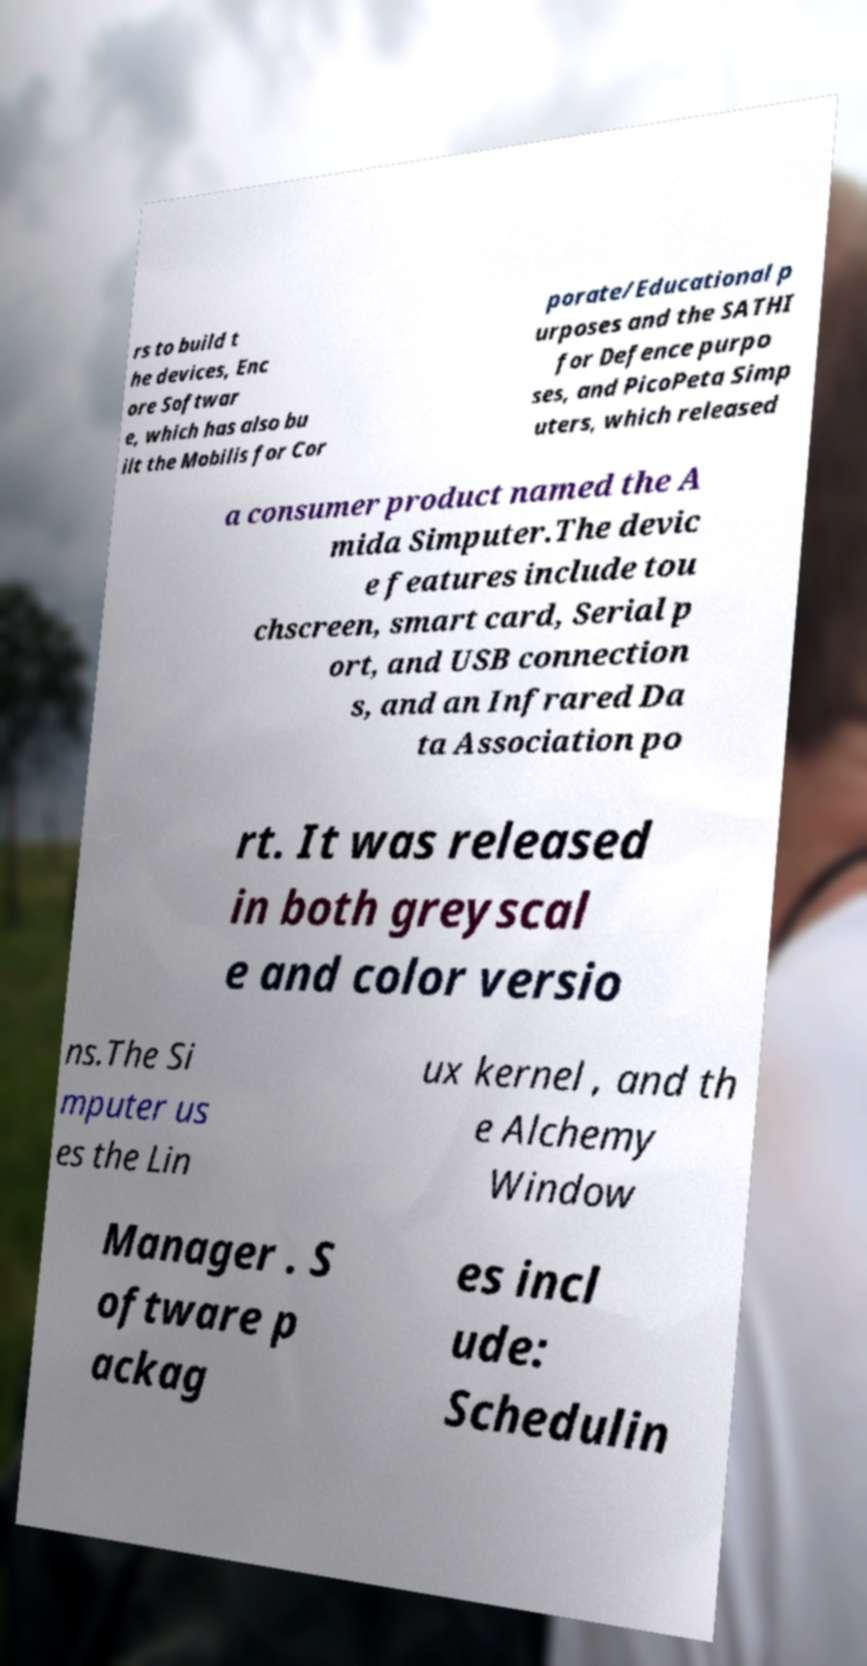Could you extract and type out the text from this image? rs to build t he devices, Enc ore Softwar e, which has also bu ilt the Mobilis for Cor porate/Educational p urposes and the SATHI for Defence purpo ses, and PicoPeta Simp uters, which released a consumer product named the A mida Simputer.The devic e features include tou chscreen, smart card, Serial p ort, and USB connection s, and an Infrared Da ta Association po rt. It was released in both greyscal e and color versio ns.The Si mputer us es the Lin ux kernel , and th e Alchemy Window Manager . S oftware p ackag es incl ude: Schedulin 